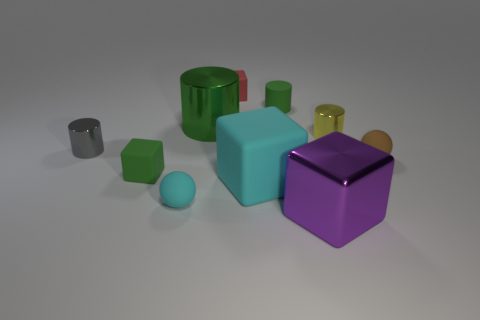Subtract all blocks. How many objects are left? 6 Subtract 0 yellow blocks. How many objects are left? 10 Subtract all tiny cylinders. Subtract all small gray objects. How many objects are left? 6 Add 3 tiny red rubber cubes. How many tiny red rubber cubes are left? 4 Add 3 big purple cubes. How many big purple cubes exist? 4 